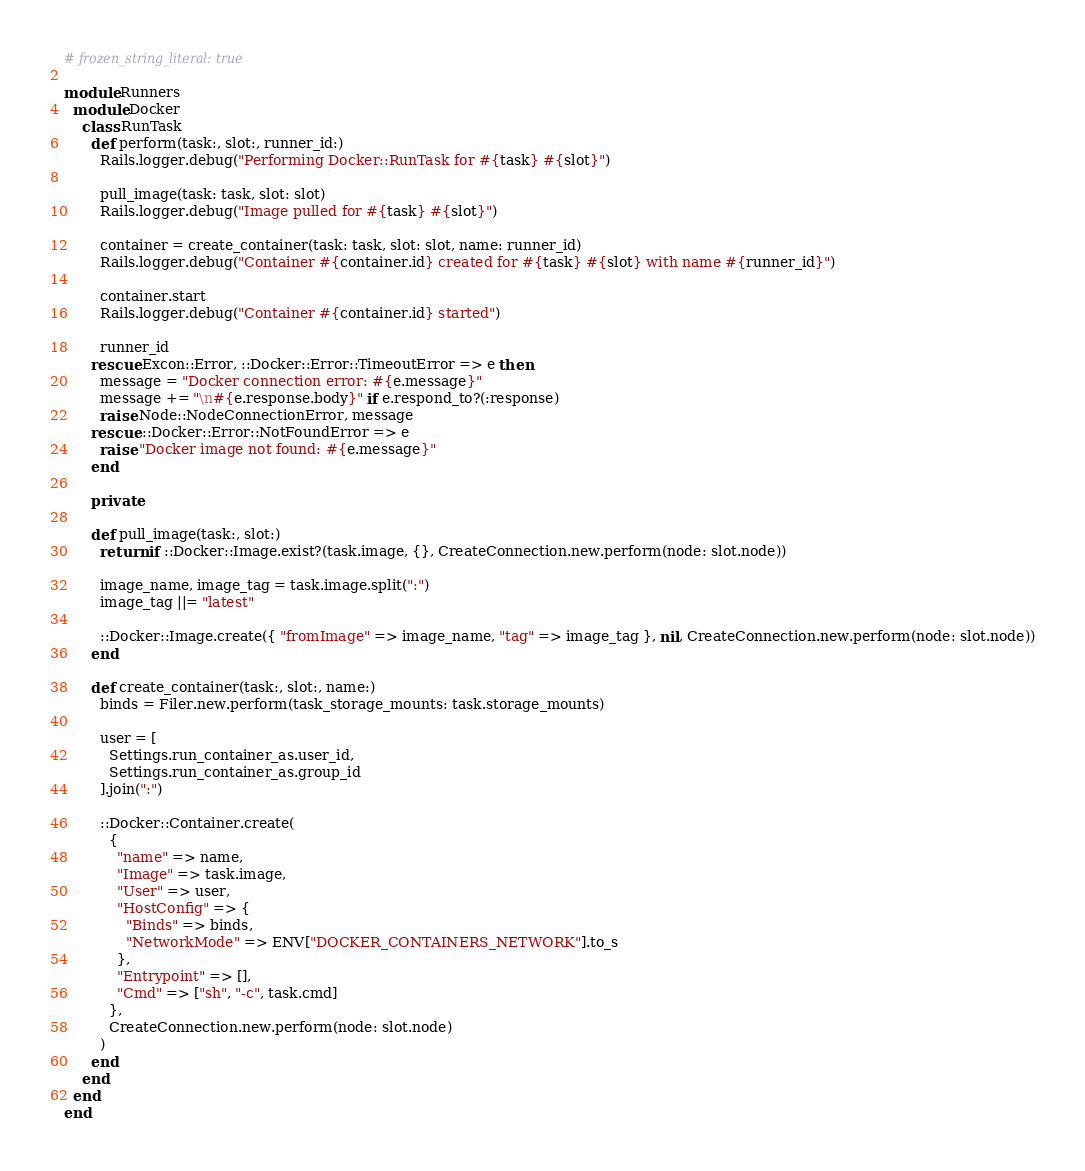Convert code to text. <code><loc_0><loc_0><loc_500><loc_500><_Ruby_># frozen_string_literal: true

module Runners
  module Docker
    class RunTask
      def perform(task:, slot:, runner_id:)
        Rails.logger.debug("Performing Docker::RunTask for #{task} #{slot}")

        pull_image(task: task, slot: slot)
        Rails.logger.debug("Image pulled for #{task} #{slot}")

        container = create_container(task: task, slot: slot, name: runner_id)
        Rails.logger.debug("Container #{container.id} created for #{task} #{slot} with name #{runner_id}")

        container.start
        Rails.logger.debug("Container #{container.id} started")

        runner_id
      rescue Excon::Error, ::Docker::Error::TimeoutError => e then
        message = "Docker connection error: #{e.message}"
        message += "\n#{e.response.body}" if e.respond_to?(:response)
        raise Node::NodeConnectionError, message
      rescue ::Docker::Error::NotFoundError => e
        raise "Docker image not found: #{e.message}"
      end

      private

      def pull_image(task:, slot:)
        return if ::Docker::Image.exist?(task.image, {}, CreateConnection.new.perform(node: slot.node))

        image_name, image_tag = task.image.split(":")
        image_tag ||= "latest"

        ::Docker::Image.create({ "fromImage" => image_name, "tag" => image_tag }, nil, CreateConnection.new.perform(node: slot.node))
      end

      def create_container(task:, slot:, name:)
        binds = Filer.new.perform(task_storage_mounts: task.storage_mounts)

        user = [
          Settings.run_container_as.user_id,
          Settings.run_container_as.group_id
        ].join(":")

        ::Docker::Container.create(
          {
            "name" => name,
            "Image" => task.image,
            "User" => user,
            "HostConfig" => {
              "Binds" => binds,
              "NetworkMode" => ENV["DOCKER_CONTAINERS_NETWORK"].to_s
            },
            "Entrypoint" => [],
            "Cmd" => ["sh", "-c", task.cmd]
          },
          CreateConnection.new.perform(node: slot.node)
        )
      end
    end
  end
end
</code> 